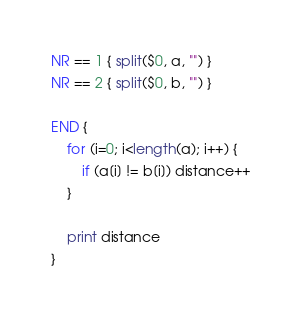<code> <loc_0><loc_0><loc_500><loc_500><_Awk_>NR == 1 { split($0, a, "") }
NR == 2 { split($0, b, "") }

END {
    for (i=0; i<length(a); i++) {
        if (a[i] != b[i]) distance++
    }

    print distance
}
</code> 